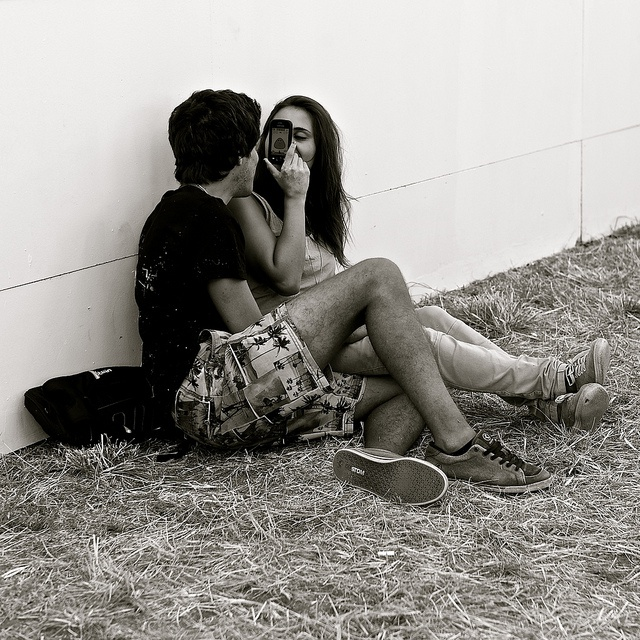Describe the objects in this image and their specific colors. I can see people in lightgray, black, gray, and darkgray tones, people in lightgray, black, gray, and darkgray tones, backpack in lightgray, black, gray, and darkgray tones, and cell phone in lightgray, black, gray, and darkgray tones in this image. 